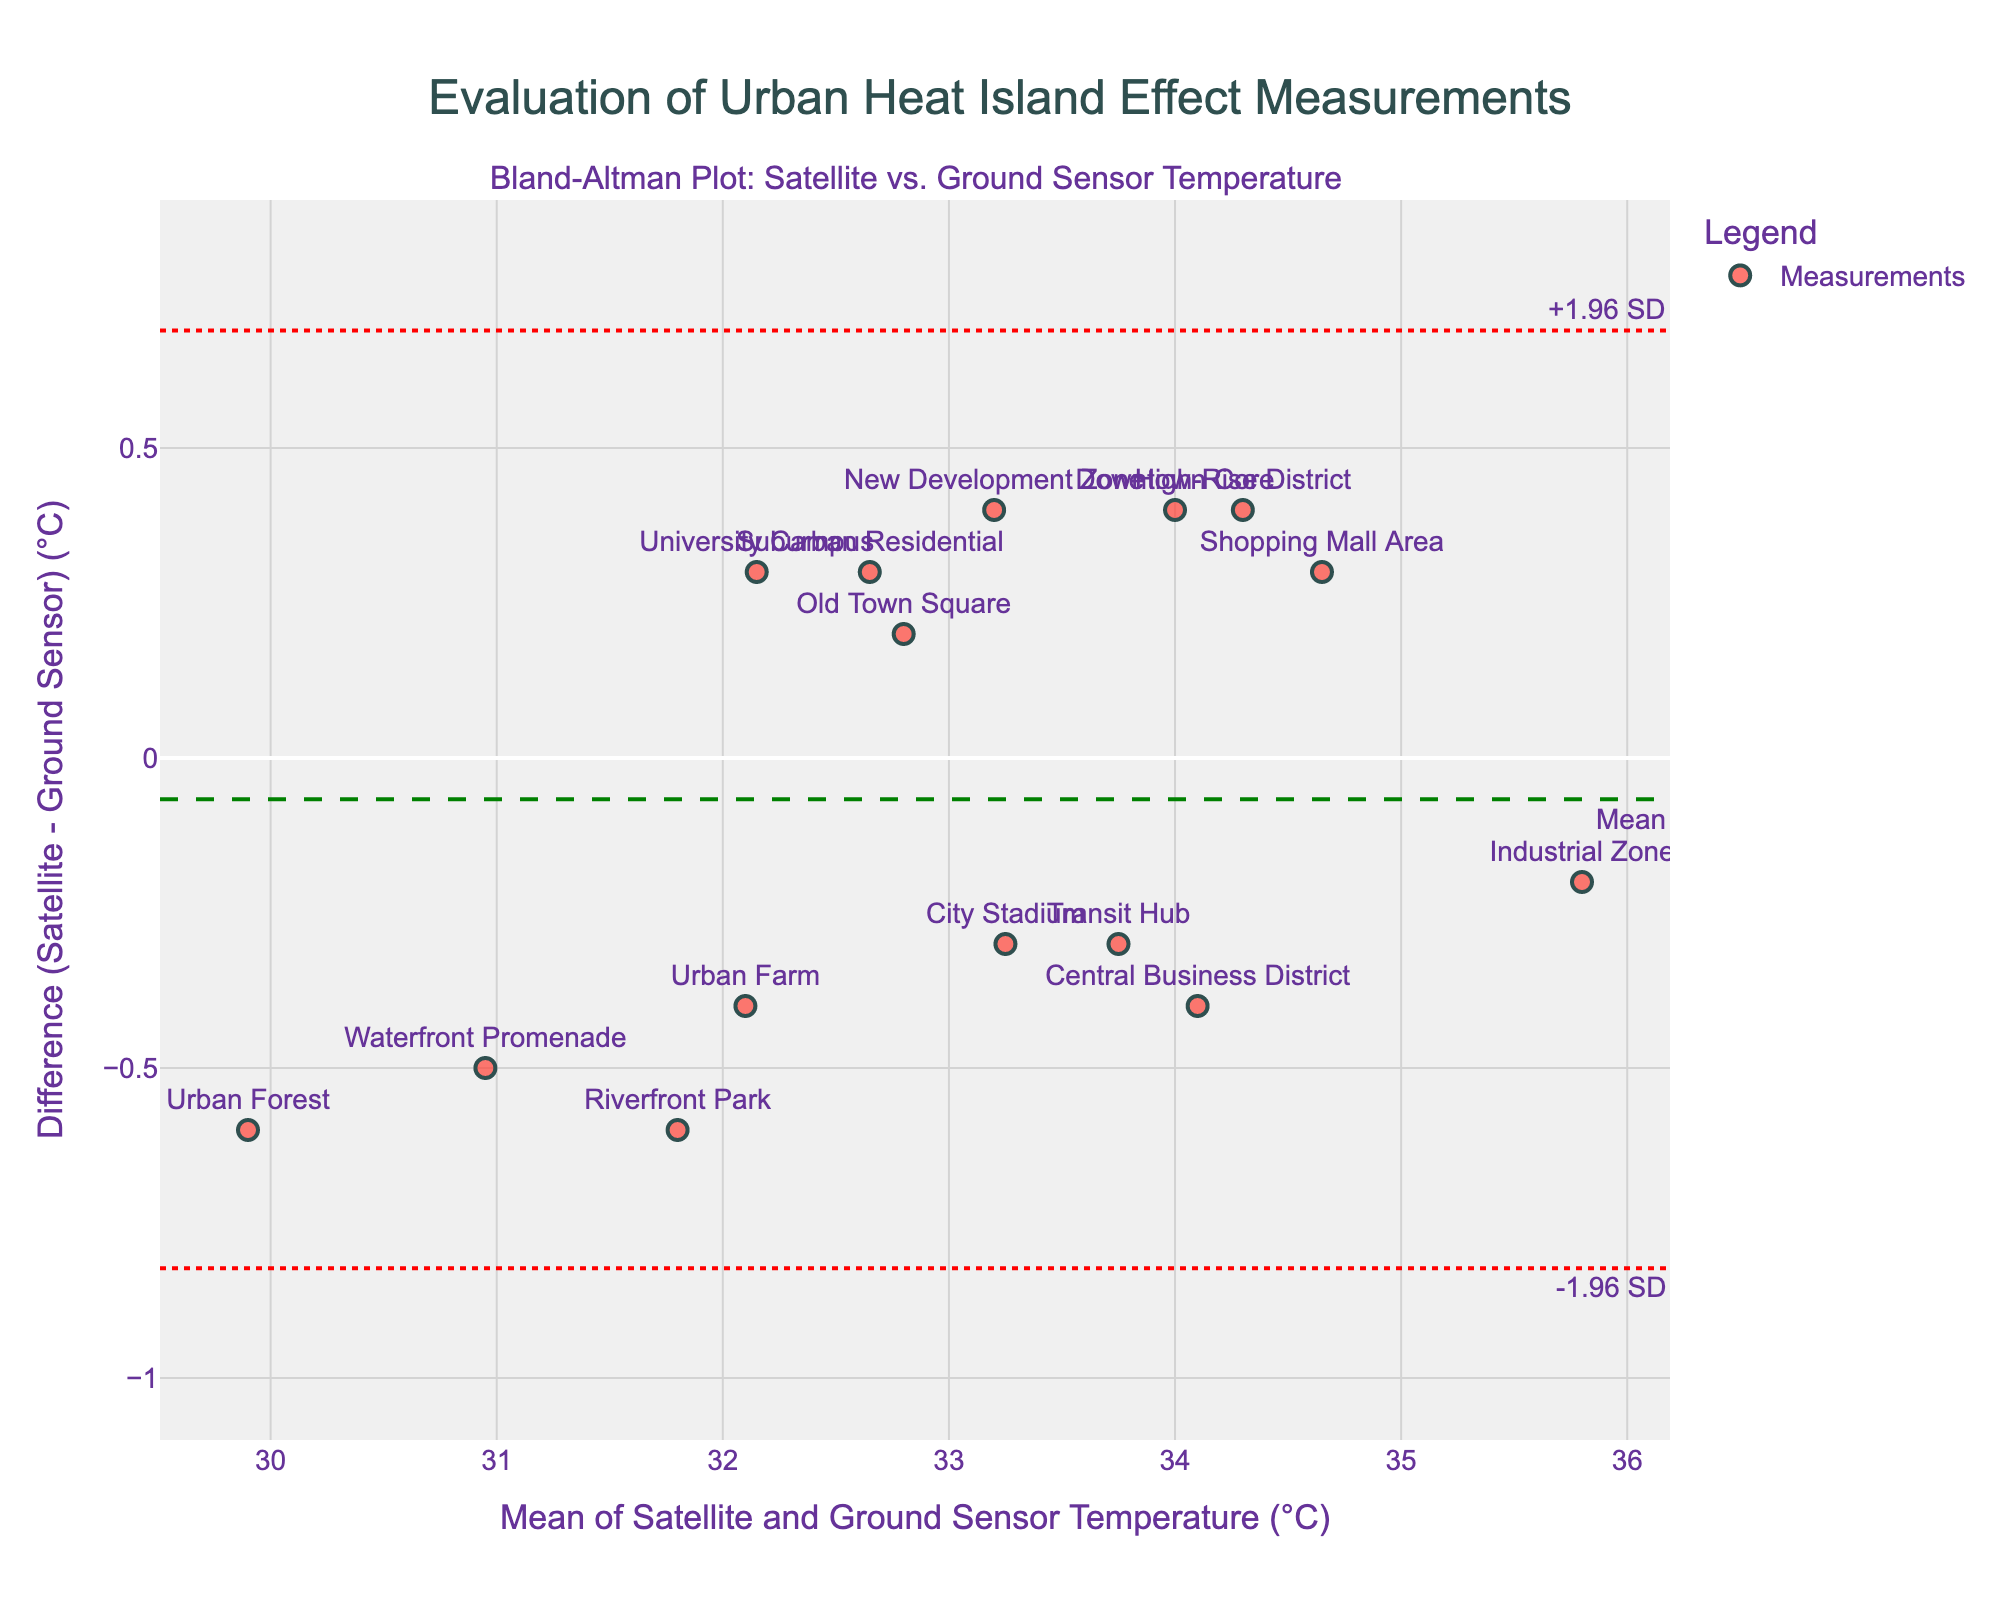How many data points are shown in the plot? By counting the number of different labeled dots on the plot, we can determine the number of data points.
Answer: 15 What is the title of the plot? The title is prominently displayed at the top of the plot.
Answer: Evaluation of Urban Heat Island Effect Measurements What is the mean difference between Satellite and Ground Sensor temperatures? The mean difference is indicated by the dashed green line labeled "Mean."
Answer: 0.08°C What are the upper and lower limits of agreement? The upper and lower limits are shown by the dotted red lines labeled "+1.96 SD" and "-1.96 SD."
Answer: +0.52°C and -0.36°C Which location has the highest mean temperature between satellite and ground sensors? The highest value on the x-axis represents the largest mean temperature value. Identify the corresponding label.
Answer: Industrial Zone Which location exhibits the greatest difference between Satellite and Ground Sensor temperatures? The greatest y-value (either positive or negative) indicates the maximal difference. Identify the corresponding label.
Answer: Urban Forest What is the range of differences in temperature between satellite and ground sensors? The range can be found by calculating the difference between the maximum and minimum y-values on the plot.
Answer: Approximately 1.0°C Are there more data points with higher satellite temperatures or higher ground sensor temperatures? Determine the number of data points above and below the mean difference line.
Answer: More points have higher satellite temperatures What is the temperature difference for the Downtown Core? Identify the label "Downtown Core" and read its y-value from the plot.
Answer: 0.4°C Is there any systematic bias observable in the plot? Evaluate if the points are evenly distributed around the mean difference or if there is a trend.
Answer: There is a slight systematic bias towards higher satellite temperatures 